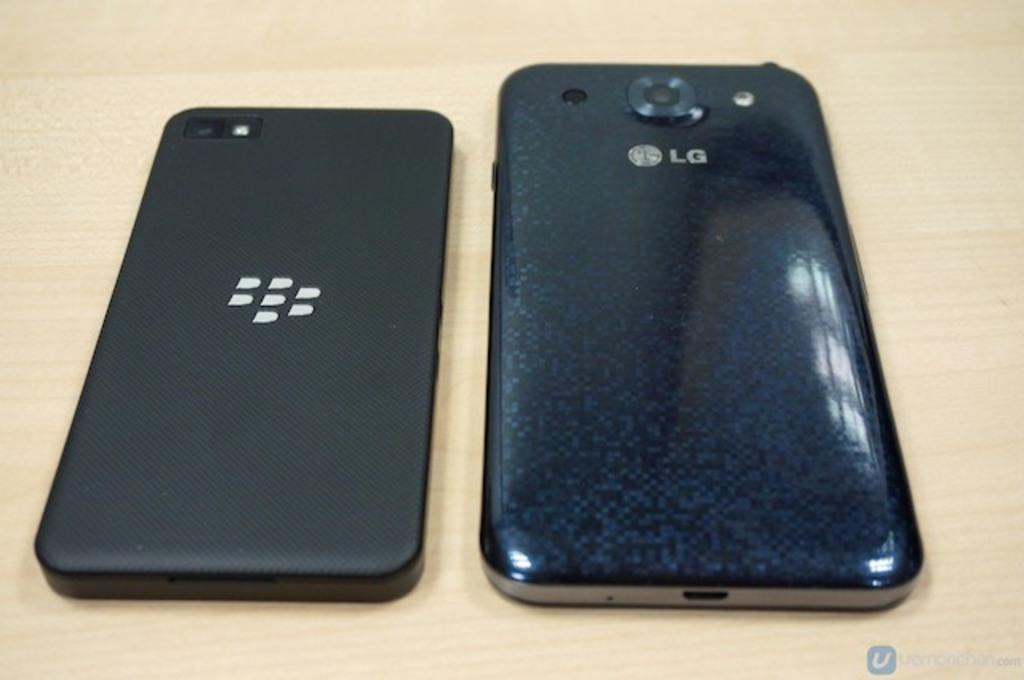<image>
Create a compact narrative representing the image presented. An LG phone sits on its face alongside another cell phone with logo. 